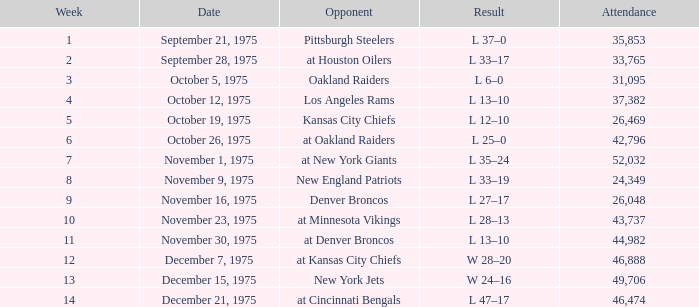Can you give me this table as a dict? {'header': ['Week', 'Date', 'Opponent', 'Result', 'Attendance'], 'rows': [['1', 'September 21, 1975', 'Pittsburgh Steelers', 'L 37–0', '35,853'], ['2', 'September 28, 1975', 'at Houston Oilers', 'L 33–17', '33,765'], ['3', 'October 5, 1975', 'Oakland Raiders', 'L 6–0', '31,095'], ['4', 'October 12, 1975', 'Los Angeles Rams', 'L 13–10', '37,382'], ['5', 'October 19, 1975', 'Kansas City Chiefs', 'L 12–10', '26,469'], ['6', 'October 26, 1975', 'at Oakland Raiders', 'L 25–0', '42,796'], ['7', 'November 1, 1975', 'at New York Giants', 'L 35–24', '52,032'], ['8', 'November 9, 1975', 'New England Patriots', 'L 33–19', '24,349'], ['9', 'November 16, 1975', 'Denver Broncos', 'L 27–17', '26,048'], ['10', 'November 23, 1975', 'at Minnesota Vikings', 'L 28–13', '43,737'], ['11', 'November 30, 1975', 'at Denver Broncos', 'L 13–10', '44,982'], ['12', 'December 7, 1975', 'at Kansas City Chiefs', 'W 28–20', '46,888'], ['13', 'December 15, 1975', 'New York Jets', 'W 24–16', '49,706'], ['14', 'December 21, 1975', 'at Cincinnati Bengals', 'L 47–17', '46,474']]} What is the earliest week when the outcome was 13-10, november 30, 1975, with over 44,982 individuals present? None. 